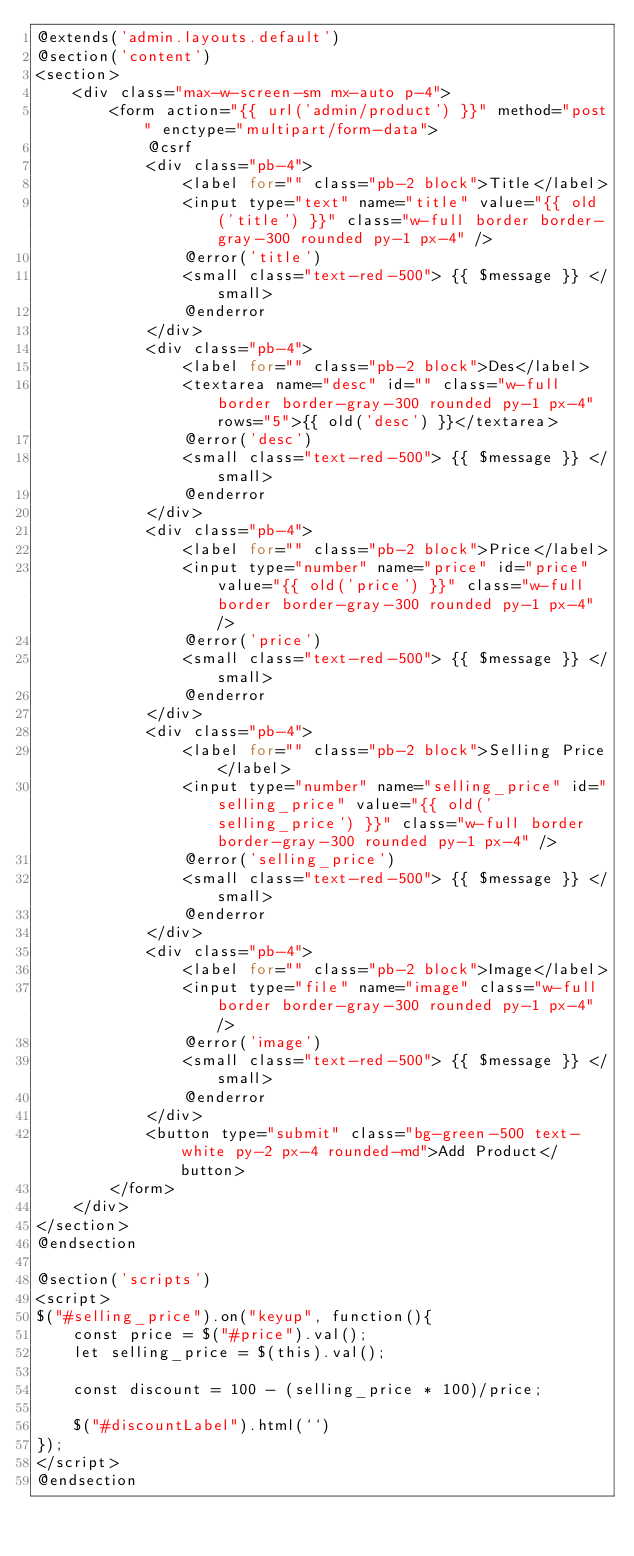<code> <loc_0><loc_0><loc_500><loc_500><_PHP_>@extends('admin.layouts.default')
@section('content')
<section>
    <div class="max-w-screen-sm mx-auto p-4">
        <form action="{{ url('admin/product') }}" method="post" enctype="multipart/form-data">
            @csrf
            <div class="pb-4">
                <label for="" class="pb-2 block">Title</label>
                <input type="text" name="title" value="{{ old('title') }}" class="w-full border border-gray-300 rounded py-1 px-4" />
                @error('title')
                <small class="text-red-500"> {{ $message }} </small>
                @enderror
            </div>
            <div class="pb-4">
                <label for="" class="pb-2 block">Des</label>
                <textarea name="desc" id="" class="w-full border border-gray-300 rounded py-1 px-4" rows="5">{{ old('desc') }}</textarea>
                @error('desc')
                <small class="text-red-500"> {{ $message }} </small>
                @enderror
            </div>
            <div class="pb-4">
                <label for="" class="pb-2 block">Price</label>
                <input type="number" name="price" id="price" value="{{ old('price') }}" class="w-full border border-gray-300 rounded py-1 px-4" />
                @error('price')
                <small class="text-red-500"> {{ $message }} </small>
                @enderror
            </div>
            <div class="pb-4">
                <label for="" class="pb-2 block">Selling Price</label>
                <input type="number" name="selling_price" id="selling_price" value="{{ old('selling_price') }}" class="w-full border border-gray-300 rounded py-1 px-4" />
                @error('selling_price')
                <small class="text-red-500"> {{ $message }} </small>
                @enderror
            </div>
            <div class="pb-4">
                <label for="" class="pb-2 block">Image</label>
                <input type="file" name="image" class="w-full border border-gray-300 rounded py-1 px-4" />
                @error('image')
                <small class="text-red-500"> {{ $message }} </small>
                @enderror
            </div>
            <button type="submit" class="bg-green-500 text-white py-2 px-4 rounded-md">Add Product</button>
        </form>
    </div>
</section>
@endsection

@section('scripts')
<script>
$("#selling_price").on("keyup", function(){
    const price = $("#price").val();
    let selling_price = $(this).val();

    const discount = 100 - (selling_price * 100)/price;
    
    $("#discountLabel").html(``)
});
</script>
@endsection</code> 